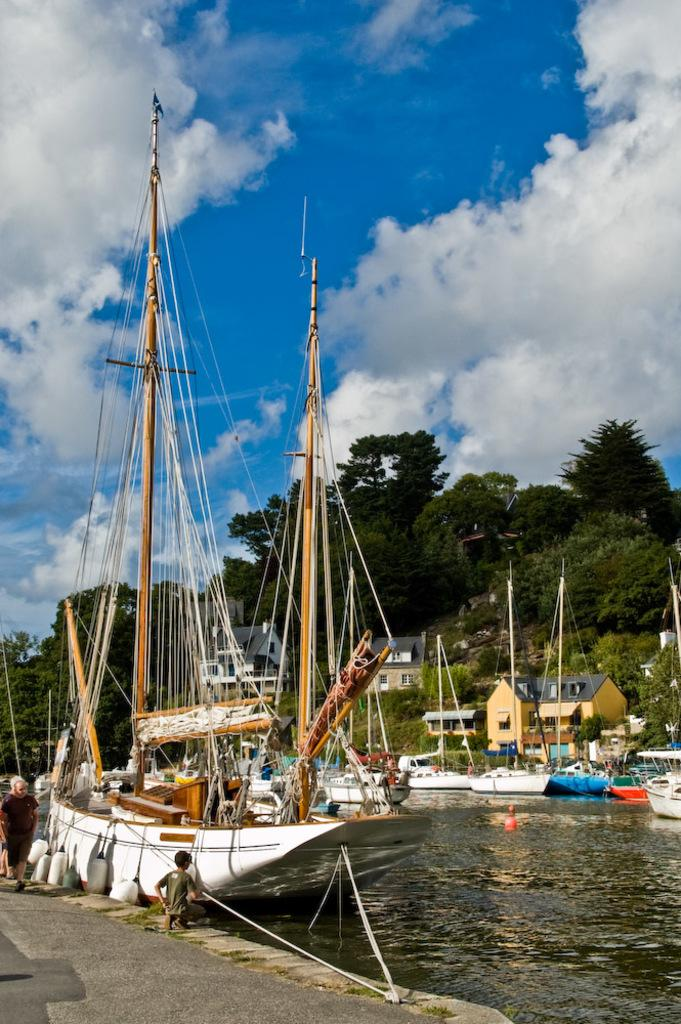What type of vehicles can be seen in the water in the image? There are boats in the water in the image. What type of structures are visible in the image? There are houses in the image. What type of vegetation is present in the image? There are trees in the image. What is happening on the road in the image? There is a group of people on the road in the image. What can be seen in the background of the image? The sky is visible in the background of the image. Can you tell if the image was taken during the day or night? The image appears to be taken during the day. Where is the oven located in the image? There is no oven present in the image. Can you see a chessboard in the image? There is no chessboard present in the image. 